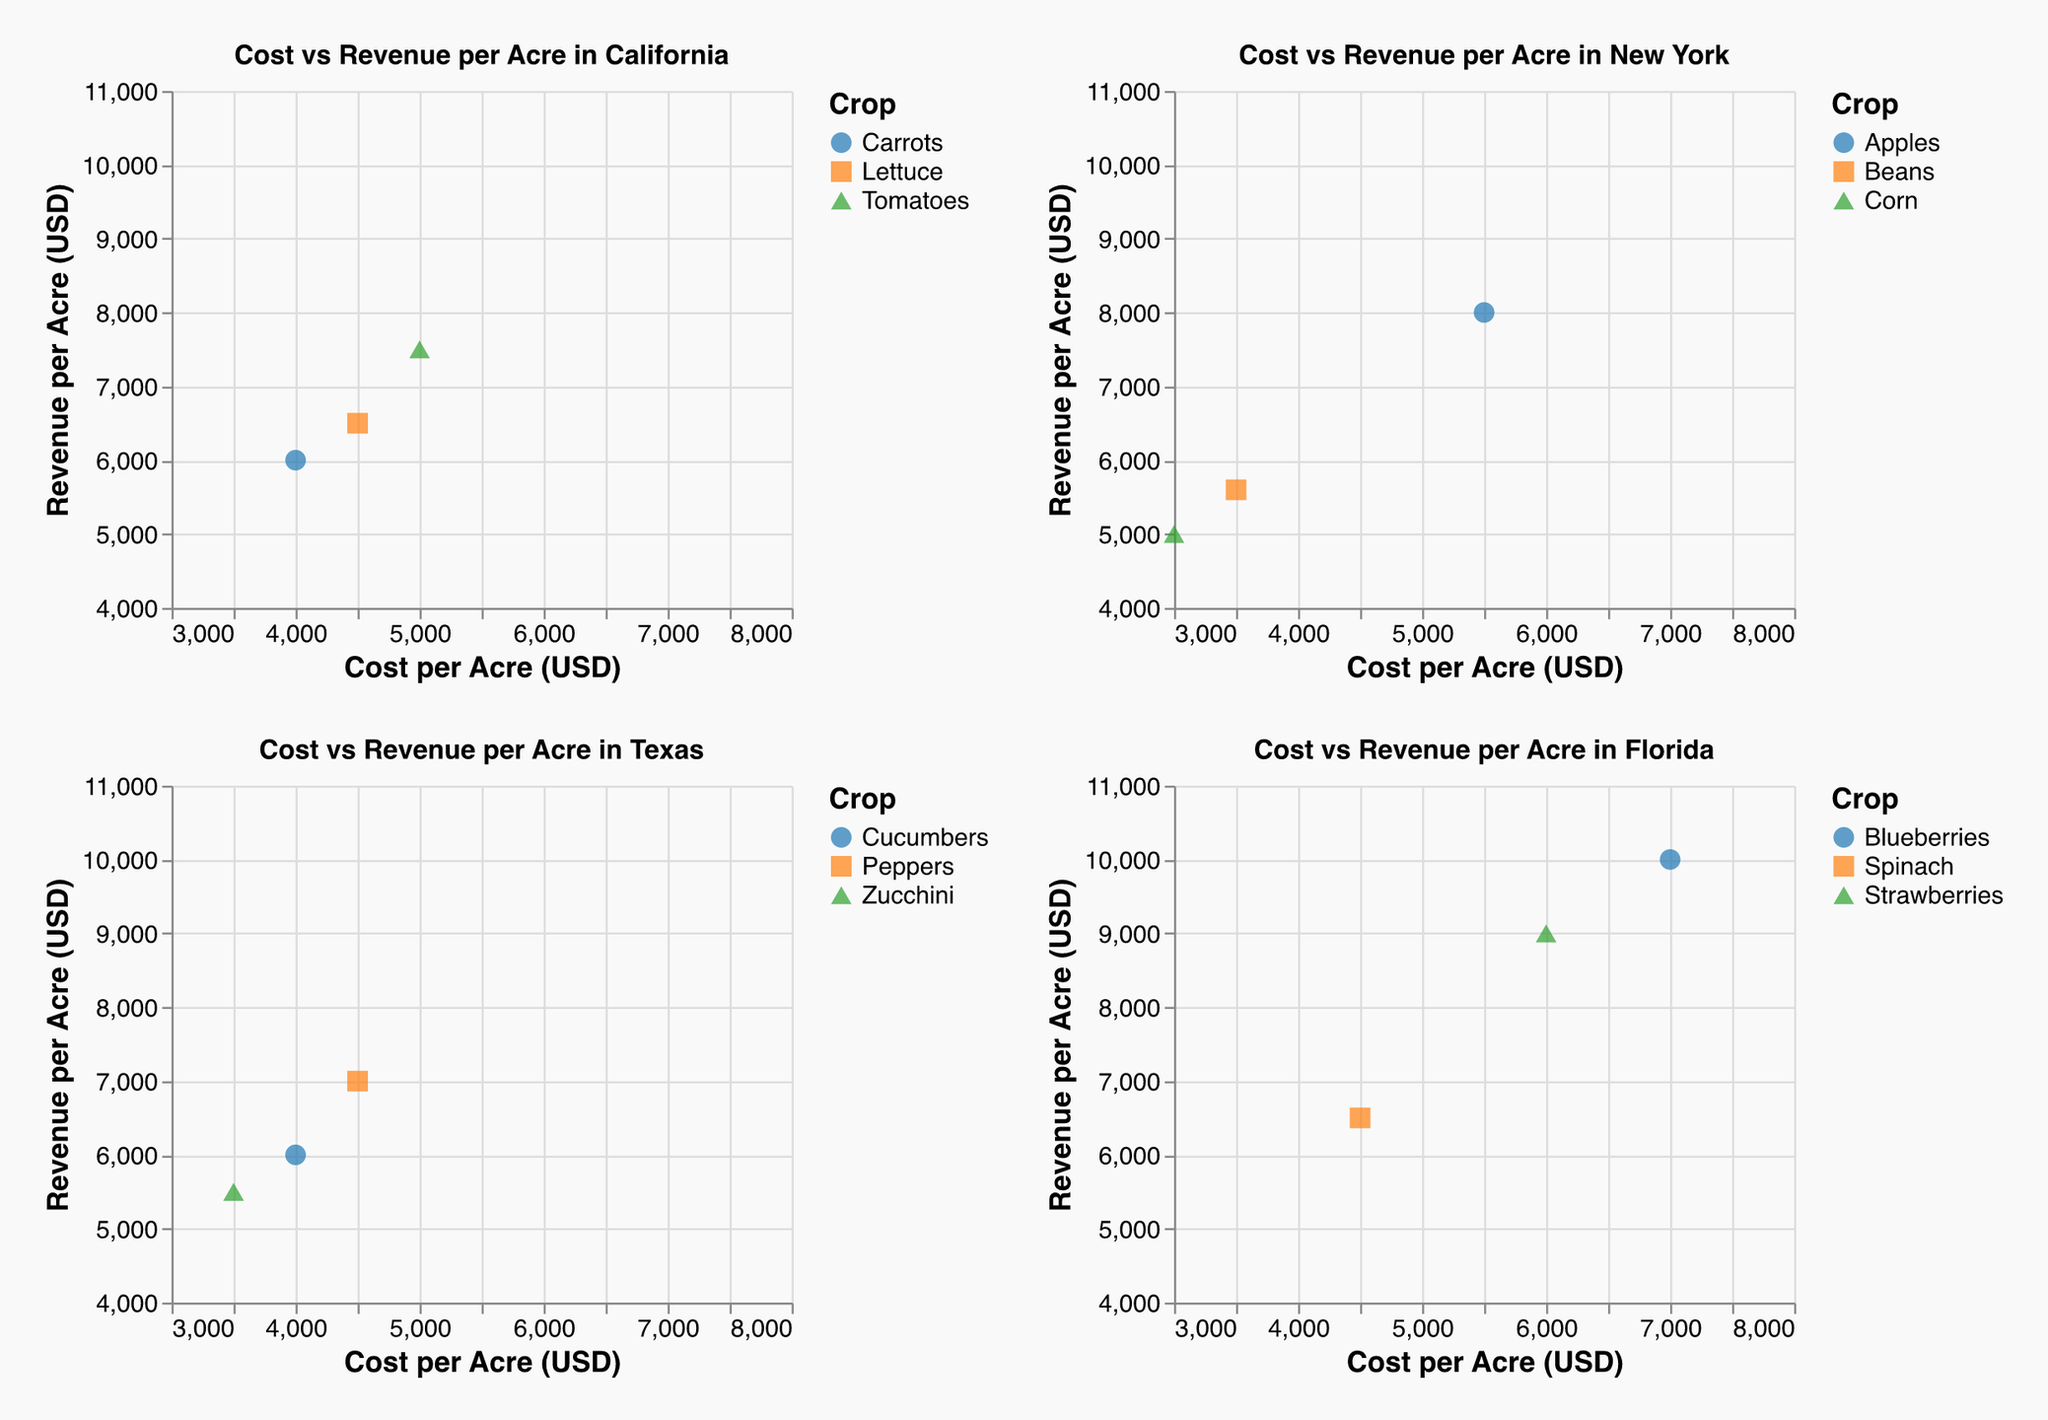What is the cost per acre for growing Zucchini in Texas? By locating the point representing Zucchini on the scatter plot for Texas, the cost per acre can be directly read from the x-axis value associated with this point.
Answer: 3500 USD How does the revenue from Apples in New York compare to the revenue from Blueberries in Florida? To compare the revenue, locate the points for Apples in the New York subplot and Blueberries in the Florida subplot. The y-axis value for Apples is 8000 USD, while for Blueberries it is 10000 USD.
Answer: Blueberries in Florida have higher revenue What is the crop with the highest revenue in California? By examining the points in the California subplot and looking at the y-axis values, Tomatoes has the highest point on the revenue scale.
Answer: Tomatoes Which crop in Texas has the lowest cost per acre? By looking at the x-axis values of the points in the Texas subplot, Zucchini has the point furthest to the left, representing the lowest cost.
Answer: Zucchini How much more does it cost to grow Blueberries in Florida than Corn in New York? Locate the x-axis values for Blueberries in Florida (7000 USD) and Corn in New York (3000 USD), and then subtract the latter from the former.
Answer: 4000 USD What is the average revenue per acre for crops in Florida? Sum the y-axis values for all crops in Florida (10000 + 9000 + 6500) and then divide by the number of crops (3).
Answer: 8500 USD Which market has the crop with the highest revenue? Examine all subplots and find the highest point on the y-axis overall, which belongs to Blueberries in Florida with revenue of 10000 USD.
Answer: Florida Is the cost per acre for growing Peppers in Texas higher than growing Lettuce in California? Compare the x-axis values: Peppers in Texas at 4500 USD vs. Lettuce in California at 4500 USD.
Answer: No, they are equal What is the total cost for growing Beans in New York and Spinach in Florida combined? Add the x-axis values for Beans in New York (3500 USD) and Spinach in Florida (4500 USD).
Answer: 8000 USD Which crop in California offers the highest profit per acre? Calculate the difference between revenue and cost for each crop in California: 
Tomatoes: 7500 - 5000 = 2500 USD 
Lettuce: 6500 - 4500 = 2000 USD 
Carrots: 6000 - 4000 = 2000 USD 
Tomatoes offer the highest profit.
Answer: Tomatoes 